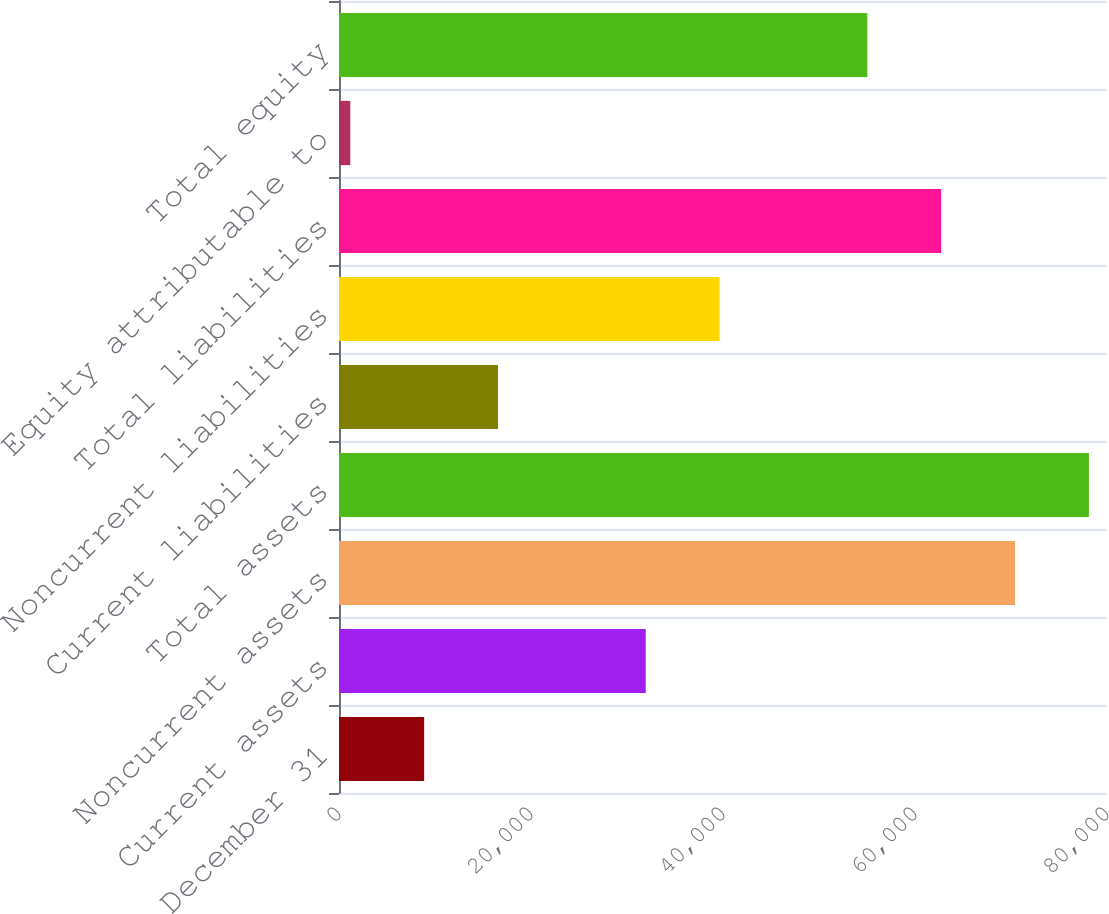<chart> <loc_0><loc_0><loc_500><loc_500><bar_chart><fcel>December 31<fcel>Current assets<fcel>Noncurrent assets<fcel>Total assets<fcel>Current liabilities<fcel>Noncurrent liabilities<fcel>Total liabilities<fcel>Equity attributable to<fcel>Total equity<nl><fcel>8869.9<fcel>31951.6<fcel>70421.1<fcel>78115<fcel>16563.8<fcel>39645.5<fcel>62727.2<fcel>1176<fcel>55033.3<nl></chart> 